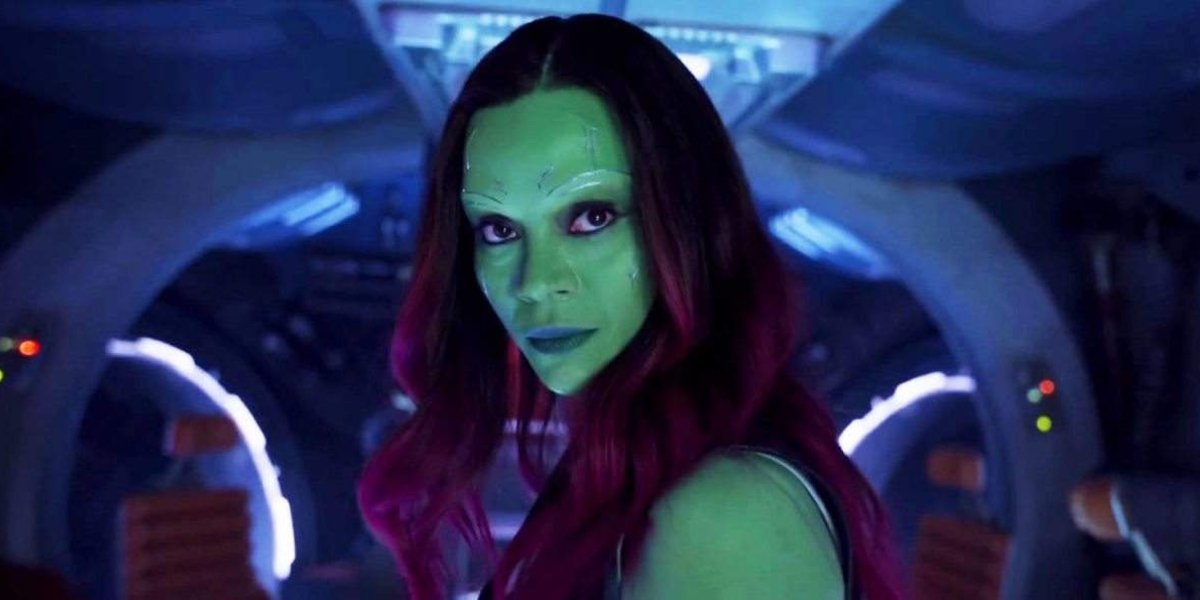What is the atmosphere of the place where this character is? The atmosphere is one of high-tech and readiness, characterized by the cool blue and soft orange lighting. The intricate design of the spaceship's control panels and the forward-looking view suggest this is a vessel meant for travel or adventure beyond the ordinary. 